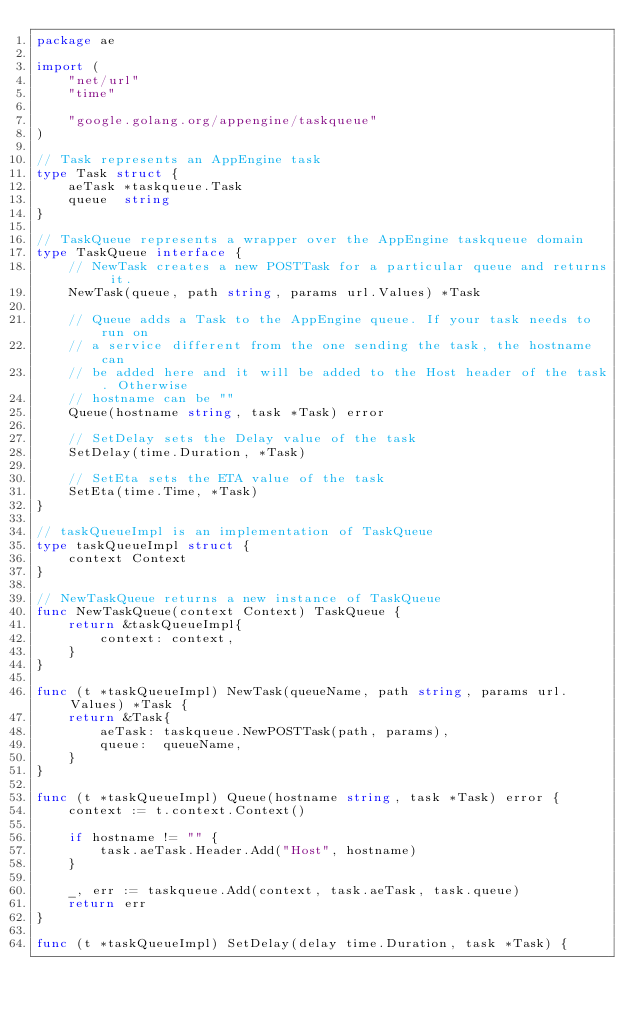<code> <loc_0><loc_0><loc_500><loc_500><_Go_>package ae

import (
	"net/url"
	"time"

	"google.golang.org/appengine/taskqueue"
)

// Task represents an AppEngine task
type Task struct {
	aeTask *taskqueue.Task
	queue  string
}

// TaskQueue represents a wrapper over the AppEngine taskqueue domain
type TaskQueue interface {
	// NewTask creates a new POSTTask for a particular queue and returns it.
	NewTask(queue, path string, params url.Values) *Task

	// Queue adds a Task to the AppEngine queue. If your task needs to run on
	// a service different from the one sending the task, the hostname can
	// be added here and it will be added to the Host header of the task. Otherwise
	// hostname can be ""
	Queue(hostname string, task *Task) error

	// SetDelay sets the Delay value of the task
	SetDelay(time.Duration, *Task)

	// SetEta sets the ETA value of the task
	SetEta(time.Time, *Task)
}

// taskQueueImpl is an implementation of TaskQueue
type taskQueueImpl struct {
	context Context
}

// NewTaskQueue returns a new instance of TaskQueue
func NewTaskQueue(context Context) TaskQueue {
	return &taskQueueImpl{
		context: context,
	}
}

func (t *taskQueueImpl) NewTask(queueName, path string, params url.Values) *Task {
	return &Task{
		aeTask: taskqueue.NewPOSTTask(path, params),
		queue:  queueName,
	}
}

func (t *taskQueueImpl) Queue(hostname string, task *Task) error {
	context := t.context.Context()

	if hostname != "" {
		task.aeTask.Header.Add("Host", hostname)
	}

	_, err := taskqueue.Add(context, task.aeTask, task.queue)
	return err
}

func (t *taskQueueImpl) SetDelay(delay time.Duration, task *Task) {</code> 